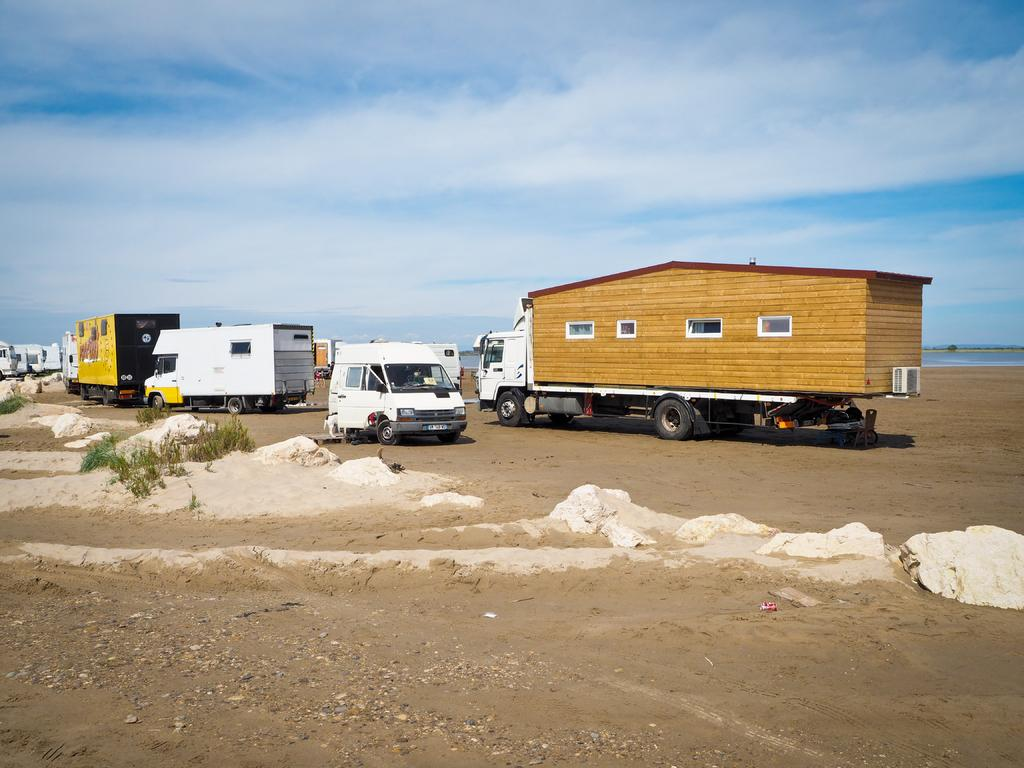What types of objects are on the ground in the image? There are vehicles on the ground in the image. What other elements can be seen on the ground? Stones are visible in the image. What else is present in the image besides vehicles and stones? There are plants in the image. What can be seen in the background of the image? The sky is visible in the background of the image. What type of sand can be seen    in the image? There is no sand present in the image. 